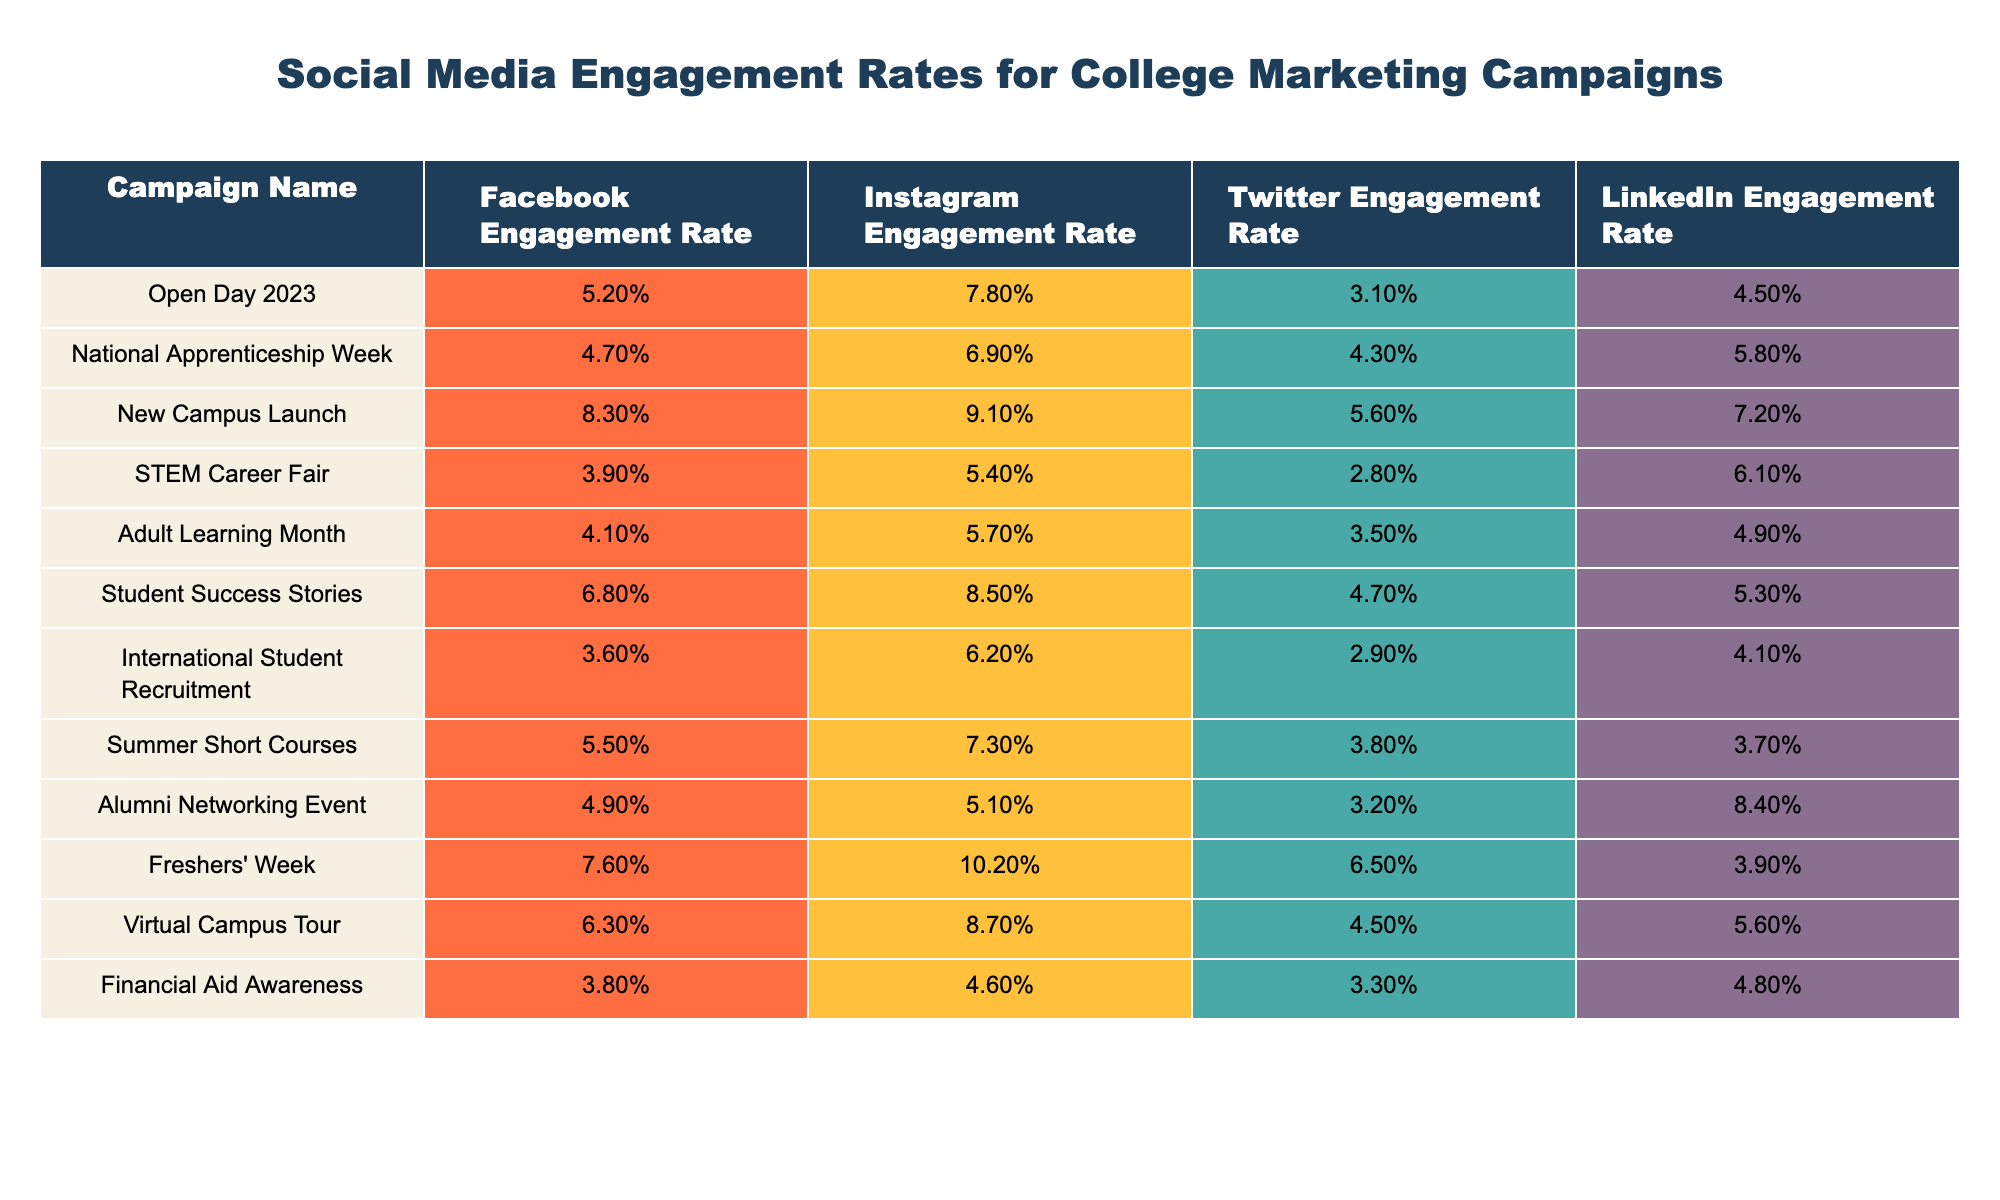What is the Facebook engagement rate for the "New Campus Launch" campaign? The table indicates the Facebook engagement rate for the "New Campus Launch" campaign is listed under that specific campaign. Looking at the corresponding column, the value is 8.3%.
Answer: 8.3% Which campaign had the highest Instagram engagement rate? By comparing the values in the Instagram engagement rate column, the "Freshers' Week" campaign has the highest rate at 10.2%.
Answer: Freshers' Week What is the average Twitter engagement rate across all campaigns? To find the average Twitter engagement rate, sum all the Twitter engagement rates: (3.1% + 4.3% + 5.6% + 2.8% + 3.5% + 4.7% + 2.9% + 3.8% + 3.2% + 6.5% + 4.5% + 3.3%) = 52.8%. Then, divide by the number of campaigns (12): 52.8% / 12 = 4.4%.
Answer: 4.4% Did the "Virtual Campus Tour" have a higher engagement rate on Facebook or Twitter? The engagement rate for the "Virtual Campus Tour" on Facebook is 6.3%, while on Twitter it is 4.5%. Since 6.3% (Facebook) is greater than 4.5% (Twitter), the Facebook engagement rate is higher.
Answer: Yes, higher on Facebook What is the difference between the highest and lowest LinkedIn engagement rates in the table? The highest LinkedIn engagement rate is 8.4% (Alumni Networking Event) and the lowest is 3.9% (Freshers' Week). The difference is calculated as 8.4% - 3.9% = 4.5%.
Answer: 4.5% Which campaign had a higher engagement rate on Instagram, "Adult Learning Month" or "Student Success Stories"? The Instagram engagement rate for "Adult Learning Month" is 5.7%, while for "Student Success Stories" it is 8.5%. Since 8.5% is greater than 5.7%, "Student Success Stories" had a higher engagement rate.
Answer: Student Success Stories How does the engagement rate for "International Student Recruitment" on Facebook compare to that of "Open Day 2023"? The Facebook engagement rate for "International Student Recruitment" is 3.6% and for "Open Day 2023" it is 5.2%. Comparing these, 3.6% is less than 5.2%, indicating that "International Student Recruitment" had a lower engagement rate.
Answer: Lower for International Student Recruitment What is the overall range of engagement rates for LinkedIn campaigns? The LinkedIn engagement rates range from 3.9% (Freshers' Week) to 8.4% (Alumni Networking Event). The range is calculated as the difference between the highest and lowest values: 8.4% - 3.9% = 4.5%. Hence, the overall range is 4.5%.
Answer: 4.5% Which platform saw the highest engagement rate for the "Summer Short Courses" campaign? The engagement rates for "Summer Short Courses" are 5.5% on Facebook, 7.3% on Instagram, 3.8% on Twitter, and 3.7% on LinkedIn. The highest among these is 7.3% on Instagram.
Answer: Instagram had the highest rate Is there a campaign where the Twitter engagement rate is below 3%? Checking the Twitter engagement rates listed in the table shows that the lowest value is 2.8% (STEM Career Fair). Since this is below 3%, the answer is yes.
Answer: Yes, for the STEM Career Fair What is the sum of engagement rates for all campaigns on Facebook? To find the sum, add all the Facebook engagement rates: (5.2% + 4.7% + 8.3% + 3.9% + 4.1% + 6.8% + 3.6% + 5.5% + 4.9% + 7.6% + 6.3% + 3.8%) = 57.9%. The sum of engagement rates for all campaigns on Facebook is therefore 57.9%.
Answer: 57.9% 